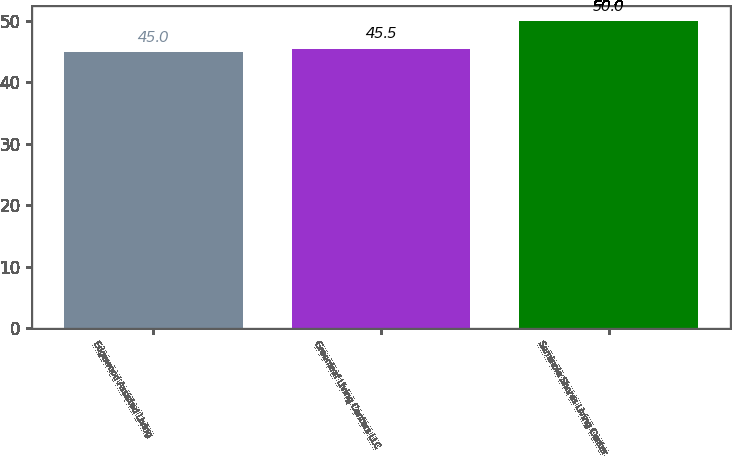Convert chart to OTSL. <chart><loc_0><loc_0><loc_500><loc_500><bar_chart><fcel>Edgewood Assisted Living<fcel>Greenleaf Living Centers LLC<fcel>Seminole Shores Living Center<nl><fcel>45<fcel>45.5<fcel>50<nl></chart> 